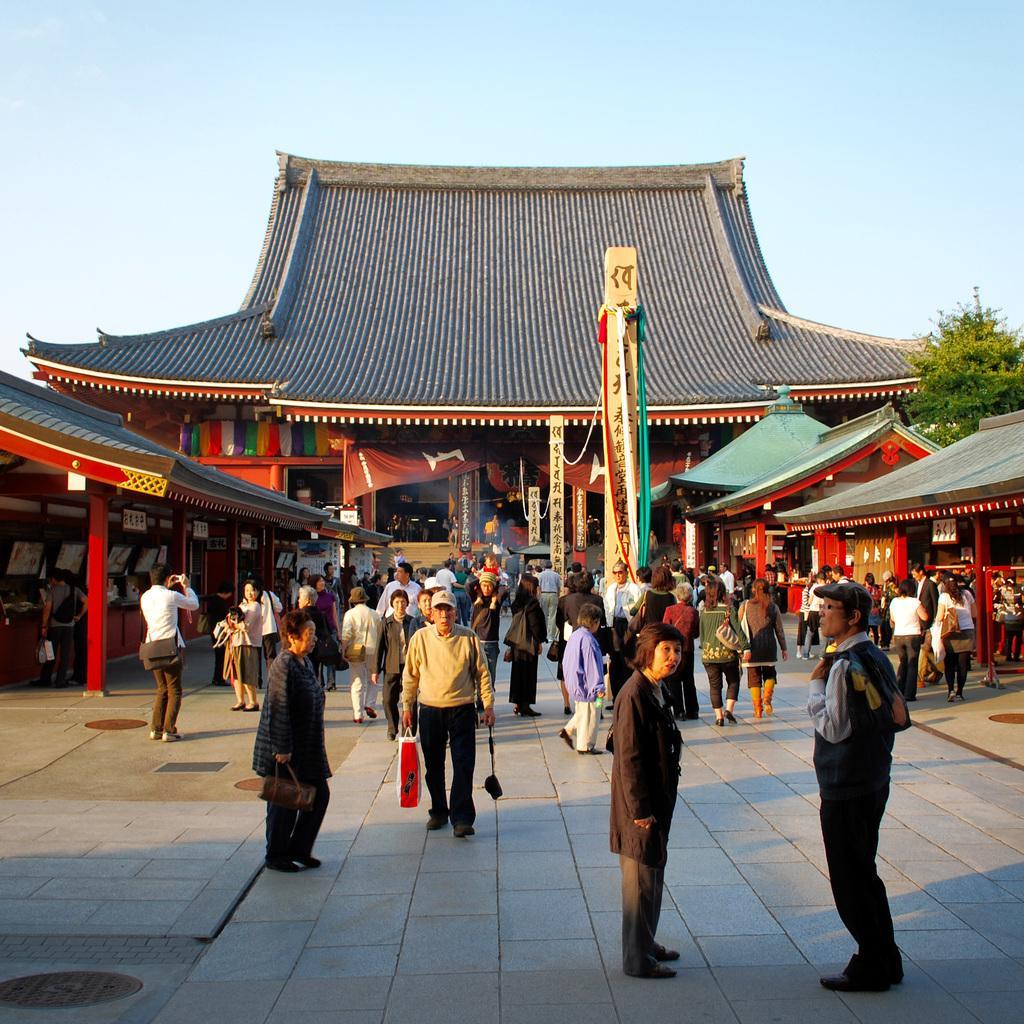Describe this image in one or two sentences. In this image we can see many people. Some are wearing caps. Some are holding bags. In the back there is a building. Also there are sheds. In the back there is a tree. In the background there is sky. 